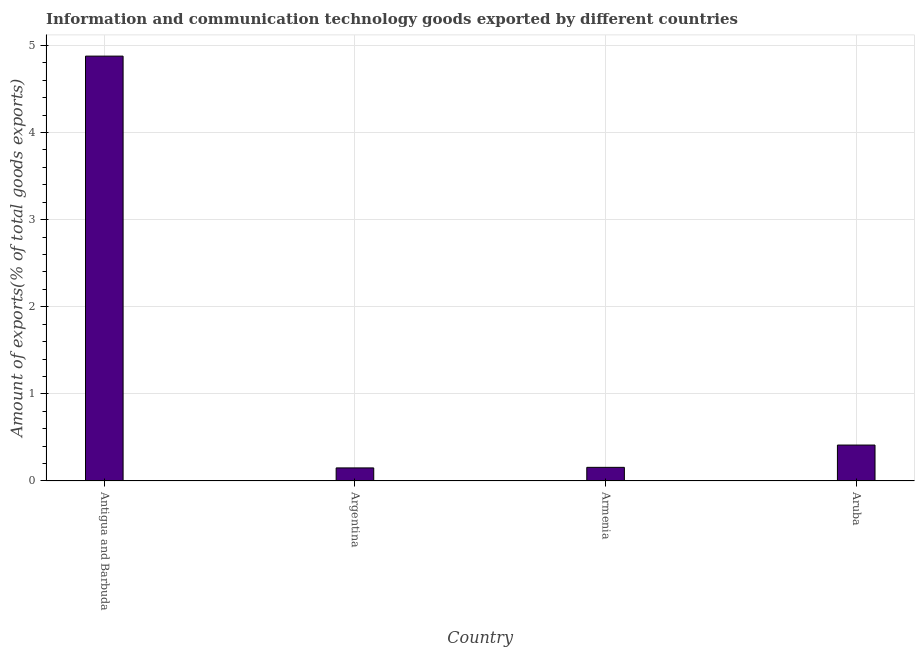Does the graph contain any zero values?
Make the answer very short. No. Does the graph contain grids?
Offer a very short reply. Yes. What is the title of the graph?
Provide a succinct answer. Information and communication technology goods exported by different countries. What is the label or title of the X-axis?
Provide a short and direct response. Country. What is the label or title of the Y-axis?
Ensure brevity in your answer.  Amount of exports(% of total goods exports). What is the amount of ict goods exports in Armenia?
Keep it short and to the point. 0.16. Across all countries, what is the maximum amount of ict goods exports?
Provide a short and direct response. 4.88. Across all countries, what is the minimum amount of ict goods exports?
Your answer should be very brief. 0.15. In which country was the amount of ict goods exports maximum?
Make the answer very short. Antigua and Barbuda. In which country was the amount of ict goods exports minimum?
Make the answer very short. Argentina. What is the sum of the amount of ict goods exports?
Keep it short and to the point. 5.6. What is the difference between the amount of ict goods exports in Argentina and Armenia?
Your response must be concise. -0.01. What is the average amount of ict goods exports per country?
Keep it short and to the point. 1.4. What is the median amount of ict goods exports?
Offer a terse response. 0.28. What is the ratio of the amount of ict goods exports in Antigua and Barbuda to that in Armenia?
Give a very brief answer. 31.13. Is the difference between the amount of ict goods exports in Antigua and Barbuda and Aruba greater than the difference between any two countries?
Offer a terse response. No. What is the difference between the highest and the second highest amount of ict goods exports?
Provide a succinct answer. 4.46. What is the difference between the highest and the lowest amount of ict goods exports?
Provide a short and direct response. 4.73. In how many countries, is the amount of ict goods exports greater than the average amount of ict goods exports taken over all countries?
Your answer should be compact. 1. Are all the bars in the graph horizontal?
Offer a terse response. No. How many countries are there in the graph?
Give a very brief answer. 4. What is the difference between two consecutive major ticks on the Y-axis?
Give a very brief answer. 1. What is the Amount of exports(% of total goods exports) of Antigua and Barbuda?
Keep it short and to the point. 4.88. What is the Amount of exports(% of total goods exports) in Argentina?
Ensure brevity in your answer.  0.15. What is the Amount of exports(% of total goods exports) in Armenia?
Provide a succinct answer. 0.16. What is the Amount of exports(% of total goods exports) of Aruba?
Your answer should be very brief. 0.41. What is the difference between the Amount of exports(% of total goods exports) in Antigua and Barbuda and Argentina?
Provide a succinct answer. 4.73. What is the difference between the Amount of exports(% of total goods exports) in Antigua and Barbuda and Armenia?
Offer a terse response. 4.72. What is the difference between the Amount of exports(% of total goods exports) in Antigua and Barbuda and Aruba?
Offer a terse response. 4.46. What is the difference between the Amount of exports(% of total goods exports) in Argentina and Armenia?
Provide a short and direct response. -0.01. What is the difference between the Amount of exports(% of total goods exports) in Argentina and Aruba?
Your answer should be very brief. -0.26. What is the difference between the Amount of exports(% of total goods exports) in Armenia and Aruba?
Make the answer very short. -0.26. What is the ratio of the Amount of exports(% of total goods exports) in Antigua and Barbuda to that in Argentina?
Offer a terse response. 32.47. What is the ratio of the Amount of exports(% of total goods exports) in Antigua and Barbuda to that in Armenia?
Give a very brief answer. 31.13. What is the ratio of the Amount of exports(% of total goods exports) in Antigua and Barbuda to that in Aruba?
Ensure brevity in your answer.  11.82. What is the ratio of the Amount of exports(% of total goods exports) in Argentina to that in Armenia?
Offer a terse response. 0.96. What is the ratio of the Amount of exports(% of total goods exports) in Argentina to that in Aruba?
Give a very brief answer. 0.36. What is the ratio of the Amount of exports(% of total goods exports) in Armenia to that in Aruba?
Make the answer very short. 0.38. 